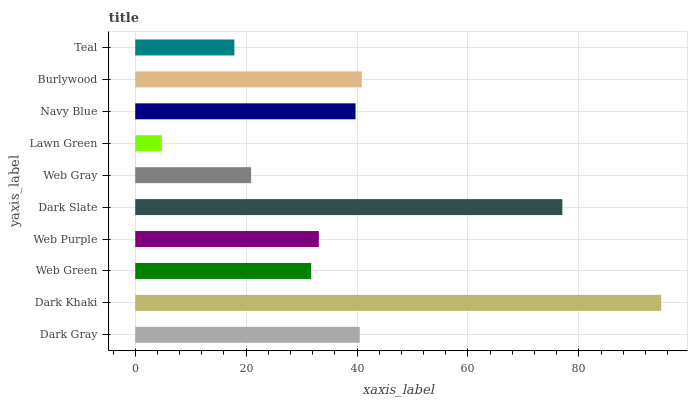Is Lawn Green the minimum?
Answer yes or no. Yes. Is Dark Khaki the maximum?
Answer yes or no. Yes. Is Web Green the minimum?
Answer yes or no. No. Is Web Green the maximum?
Answer yes or no. No. Is Dark Khaki greater than Web Green?
Answer yes or no. Yes. Is Web Green less than Dark Khaki?
Answer yes or no. Yes. Is Web Green greater than Dark Khaki?
Answer yes or no. No. Is Dark Khaki less than Web Green?
Answer yes or no. No. Is Navy Blue the high median?
Answer yes or no. Yes. Is Web Purple the low median?
Answer yes or no. Yes. Is Lawn Green the high median?
Answer yes or no. No. Is Dark Gray the low median?
Answer yes or no. No. 